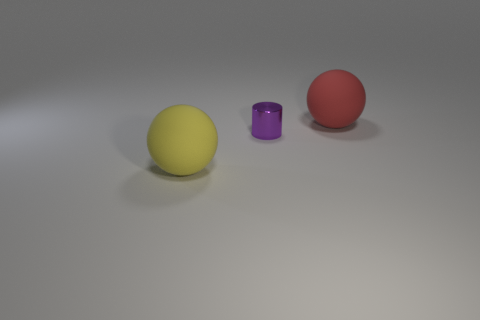Are there more large matte spheres that are to the left of the tiny metal thing than green matte balls? Indeed, there are more large matte spheres to the left of the tiny metal object. The image shows one yellow large matte sphere and one red large matte sphere positioned to the left of the purple metallic cylinder, while there are no green matte balls present. 